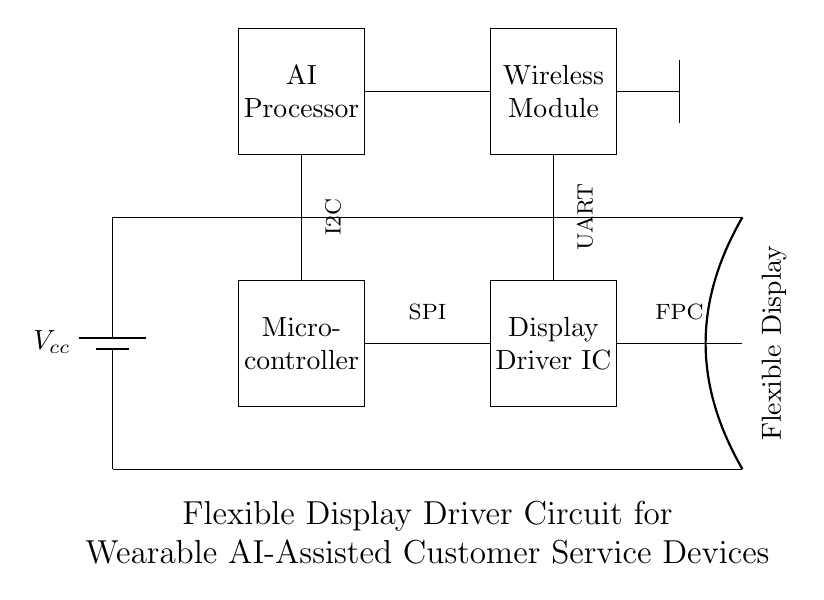What is the primary power source for this circuit? The primary power source is indicated by the battery symbol, labeled Vcc, which supplies voltage to the circuit.
Answer: Vcc What type of microcontroller is used in this circuit? The circuit diagram displays a rectangle labeled "Microcontroller," which signifies the component type, but does not provide specific model information.
Answer: Microcontroller How is the AI processor connected to the microcontroller? The AI processor is connected to the microcontroller through a vertical line representing a direct connection, suggesting communication between the two.
Answer: Direct connection What communication protocols are indicated in this circuit diagram? The diagram shows three labels: SPI, I2C, and UART, which are standard communication protocols used for data transmission between components.
Answer: SPI, I2C, UART Which component drives the flexible display? The display is driven by the Display Driver IC, shown as a rectangle labeled with this term in the diagram.
Answer: Display Driver IC How many main components are present in the circuit? The components in the circuit include the power supply, microcontroller, display driver IC, flexible display, AI processor, and wireless module, totaling six main components.
Answer: Six 